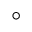Convert formula to latex. <formula><loc_0><loc_0><loc_500><loc_500>^ { \circ }</formula> 